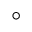Convert formula to latex. <formula><loc_0><loc_0><loc_500><loc_500>^ { \circ }</formula> 